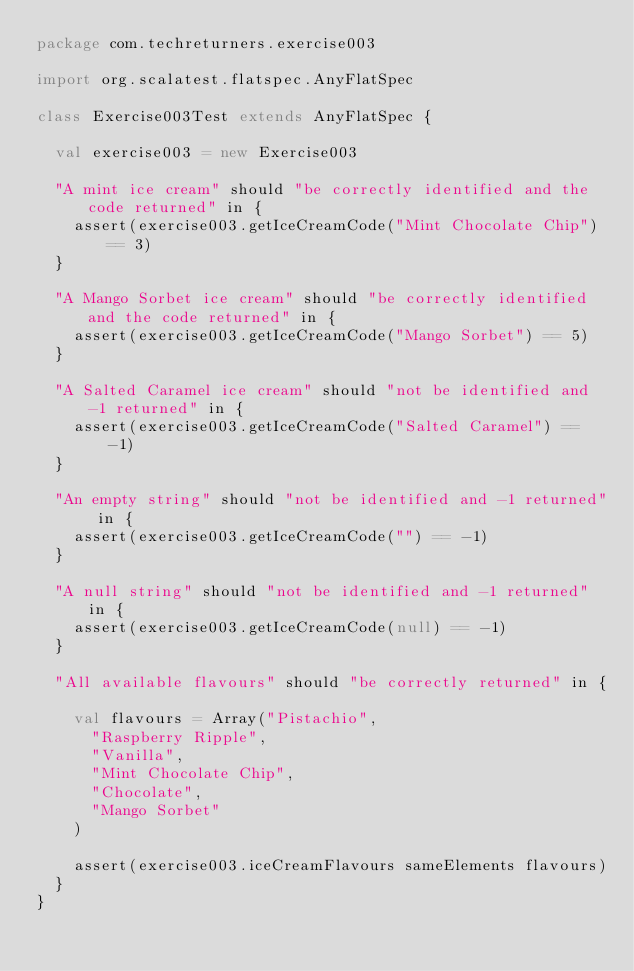<code> <loc_0><loc_0><loc_500><loc_500><_Scala_>package com.techreturners.exercise003

import org.scalatest.flatspec.AnyFlatSpec

class Exercise003Test extends AnyFlatSpec {

  val exercise003 = new Exercise003

  "A mint ice cream" should "be correctly identified and the code returned" in {
    assert(exercise003.getIceCreamCode("Mint Chocolate Chip") == 3)
  }

  "A Mango Sorbet ice cream" should "be correctly identified and the code returned" in {
    assert(exercise003.getIceCreamCode("Mango Sorbet") == 5)
  }

  "A Salted Caramel ice cream" should "not be identified and -1 returned" in {
    assert(exercise003.getIceCreamCode("Salted Caramel") == -1)
  }

  "An empty string" should "not be identified and -1 returned" in {
    assert(exercise003.getIceCreamCode("") == -1)
  }

  "A null string" should "not be identified and -1 returned" in {
    assert(exercise003.getIceCreamCode(null) == -1)
  }

  "All available flavours" should "be correctly returned" in {

    val flavours = Array("Pistachio",
      "Raspberry Ripple",
      "Vanilla",
      "Mint Chocolate Chip",
      "Chocolate",
      "Mango Sorbet"
    )

    assert(exercise003.iceCreamFlavours sameElements flavours)
  }
}
</code> 